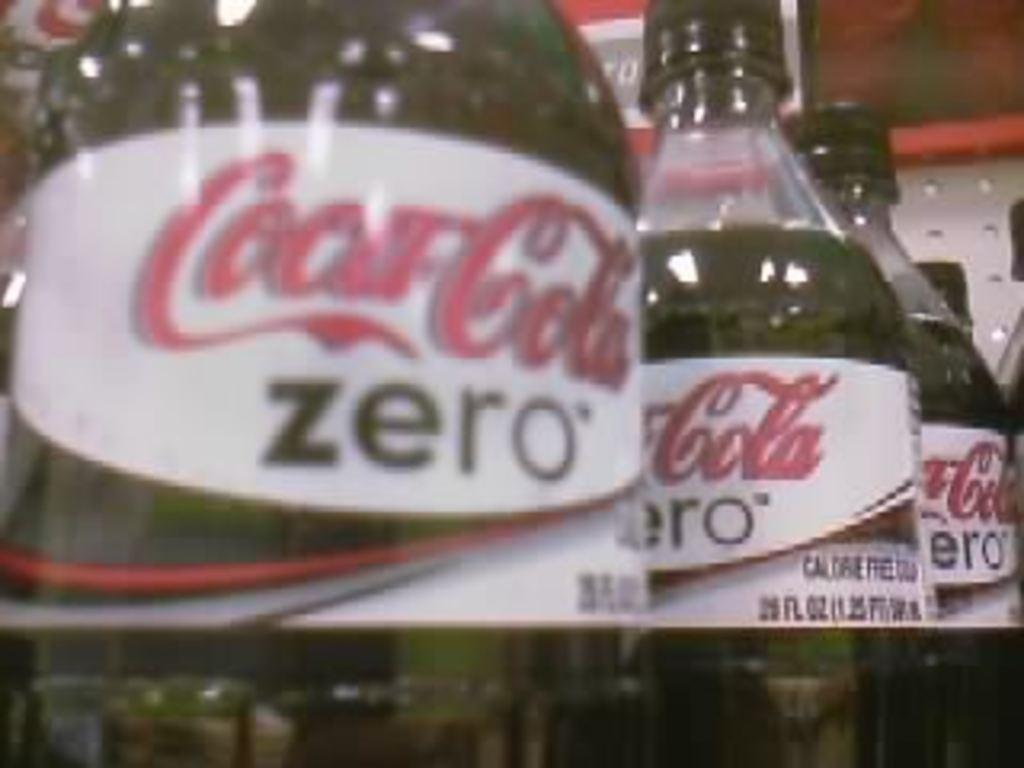What is the main subject of the image? The main subject of the image is a group of bottles. What is written on the bottles? The bottles have "Coca-Cola Zero" written on them. What type of cake is being served in the image? There is no cake present in the image; it features a group of bottles with "Coca-Cola Zero" written on them. How many trees are visible in the image? There are no trees visible in the image; it features a group of bottles with "Coca-Cola Zero" written on them. 